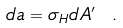Convert formula to latex. <formula><loc_0><loc_0><loc_500><loc_500>d a = \sigma _ { H } d A ^ { \prime } \ .</formula> 